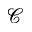Convert formula to latex. <formula><loc_0><loc_0><loc_500><loc_500>\mathcal { C }</formula> 